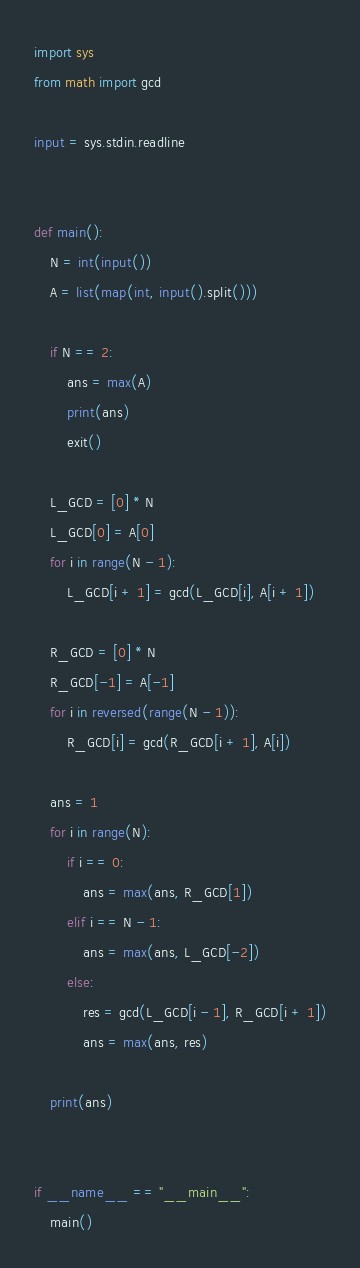<code> <loc_0><loc_0><loc_500><loc_500><_Python_>import sys
from math import gcd

input = sys.stdin.readline


def main():
    N = int(input())
    A = list(map(int, input().split()))

    if N == 2:
        ans = max(A)
        print(ans)
        exit()

    L_GCD = [0] * N
    L_GCD[0] = A[0]
    for i in range(N - 1):
        L_GCD[i + 1] = gcd(L_GCD[i], A[i + 1])

    R_GCD = [0] * N
    R_GCD[-1] = A[-1]
    for i in reversed(range(N - 1)):
        R_GCD[i] = gcd(R_GCD[i + 1], A[i])

    ans = 1
    for i in range(N):
        if i == 0:
            ans = max(ans, R_GCD[1])
        elif i == N - 1:
            ans = max(ans, L_GCD[-2])
        else:
            res = gcd(L_GCD[i - 1], R_GCD[i + 1])
            ans = max(ans, res)

    print(ans)


if __name__ == "__main__":
    main()
</code> 